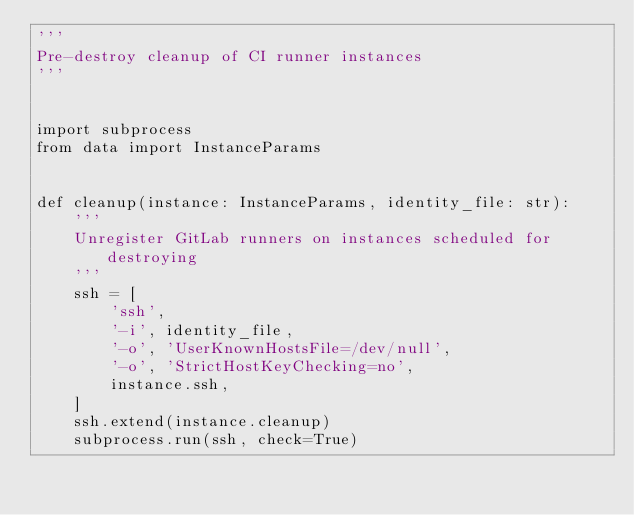<code> <loc_0><loc_0><loc_500><loc_500><_Python_>'''
Pre-destroy cleanup of CI runner instances
'''


import subprocess
from data import InstanceParams


def cleanup(instance: InstanceParams, identity_file: str):
    '''
    Unregister GitLab runners on instances scheduled for destroying
    '''
    ssh = [
        'ssh',
        '-i', identity_file,
        '-o', 'UserKnownHostsFile=/dev/null',
        '-o', 'StrictHostKeyChecking=no',
        instance.ssh,
    ]
    ssh.extend(instance.cleanup)
    subprocess.run(ssh, check=True)
</code> 